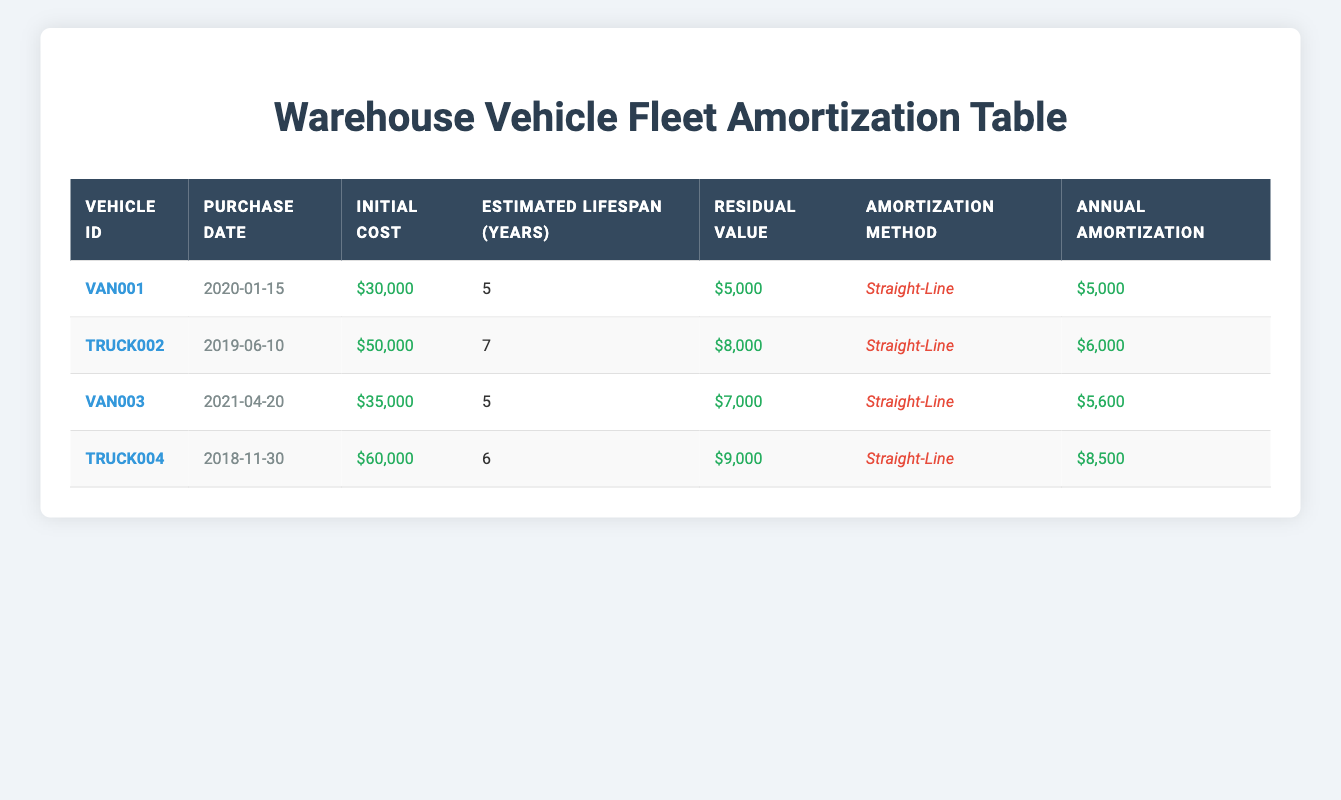What is the initial cost of VAN001? The table lists the vehicle details, including the initial cost, and for VAN001, the initial cost is shown as $30,000.
Answer: $30,000 How many years is the estimated lifespan of TRUCK002? Referring to the table, TRUCK002 has an estimated lifespan labeled as 7 years.
Answer: 7 years What is the residual value of VAN003? In the table, the residual value for VAN003 is listed as $7,000.
Answer: $7,000 What is the total annual amortization for all vehicles? To find the total annual amortization, we sum the annual amortization values: $5,000 (VAN001) + $6,000 (TRUCK002) + $5,600 (VAN003) + $8,500 (TRUCK004) = $25,100.
Answer: $25,100 Does TRUCK004 have a higher initial cost than VAN003? The initial cost for TRUCK004 is $60,000, and for VAN003, it is $35,000. Since $60,000 is greater than $35,000, the answer is yes.
Answer: Yes What is the average annual amortization for the vehicles? To find the average, we sum the annual amortization amounts: $5,000 + $6,000 + $5,600 + $8,500 = $25,100. Then divide by the number of vehicles, which is 4, giving an average of $25,100 / 4 = $6,275.
Answer: $6,275 Is the estimated lifespan of VAN001 fewer years than that of TRUCK002? VAN001 has an estimated lifespan of 5 years, whereas TRUCK002 has an estimated lifespan of 7 years. Since 5 years is less than 7 years, the answer is yes.
Answer: Yes Which vehicle has the highest annual amortization? Comparing the annual amortization values, TRUCK004 at $8,500 has the highest value compared to the others: $5,000, $6,000, and $5,600.
Answer: TRUCK004 What is the difference in initial cost between TRUCK002 and TRUCK004? The initial cost for TRUCK002 is $50,000 and for TRUCK004, it is $60,000. The difference is $60,000 - $50,000 = $10,000.
Answer: $10,000 